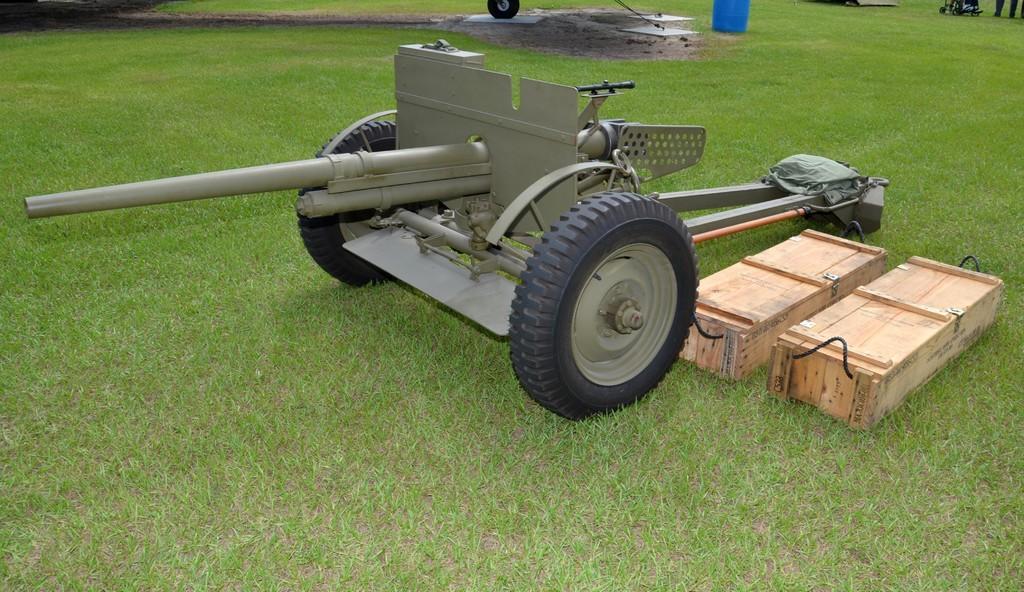Describe this image in one or two sentences. This image consists of grass. There is a drum at the top. There is something like vehicle in the middle. It has wheels. There are two boxes on the right side. There is person's leg at the top. 